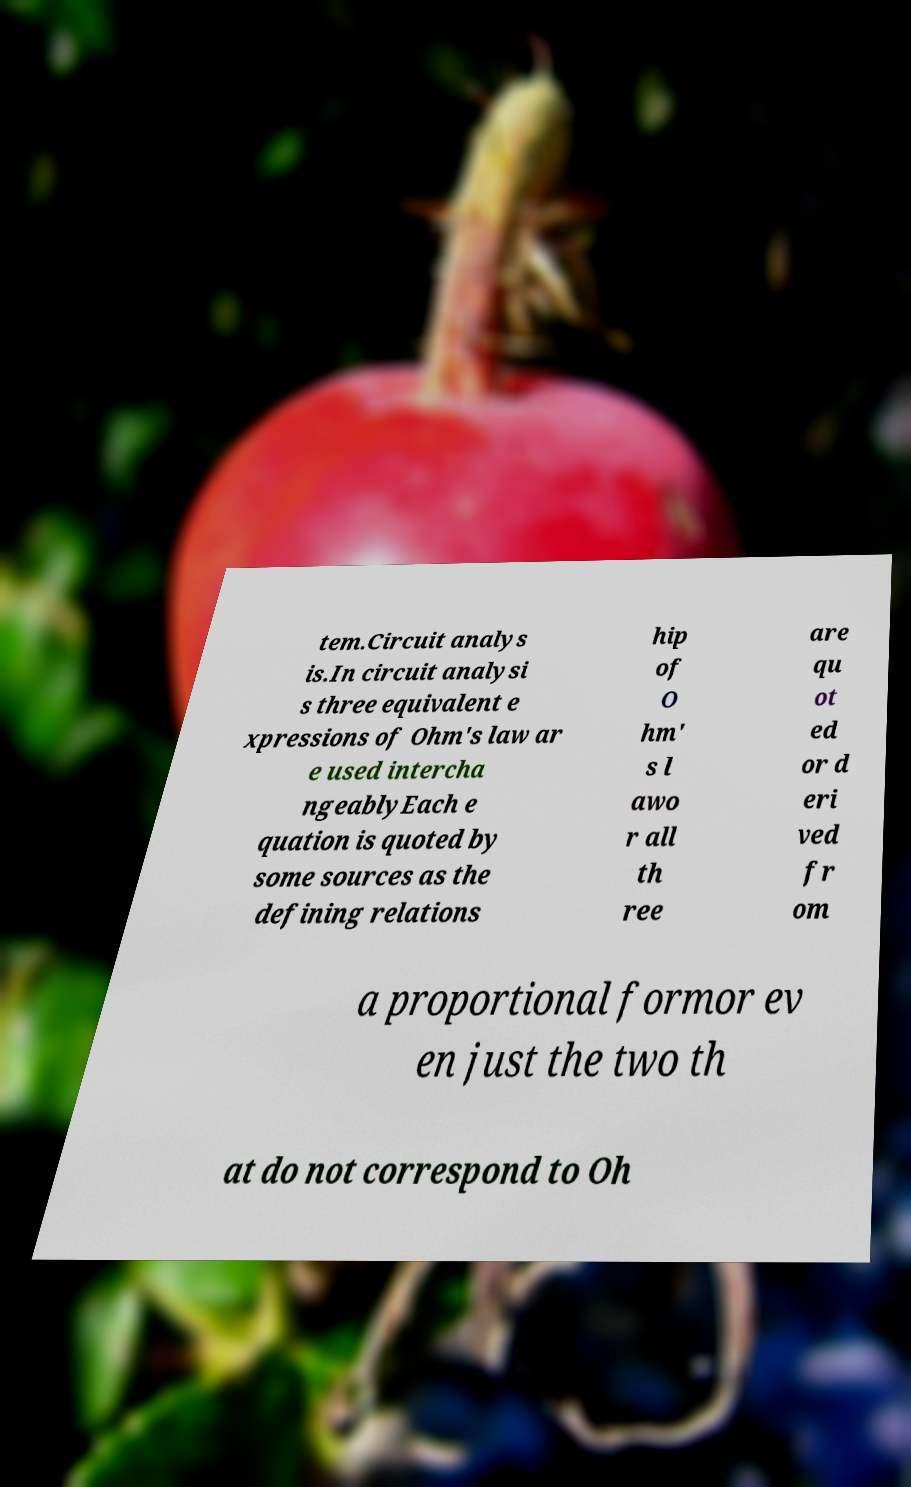What messages or text are displayed in this image? I need them in a readable, typed format. tem.Circuit analys is.In circuit analysi s three equivalent e xpressions of Ohm's law ar e used intercha ngeablyEach e quation is quoted by some sources as the defining relations hip of O hm' s l awo r all th ree are qu ot ed or d eri ved fr om a proportional formor ev en just the two th at do not correspond to Oh 